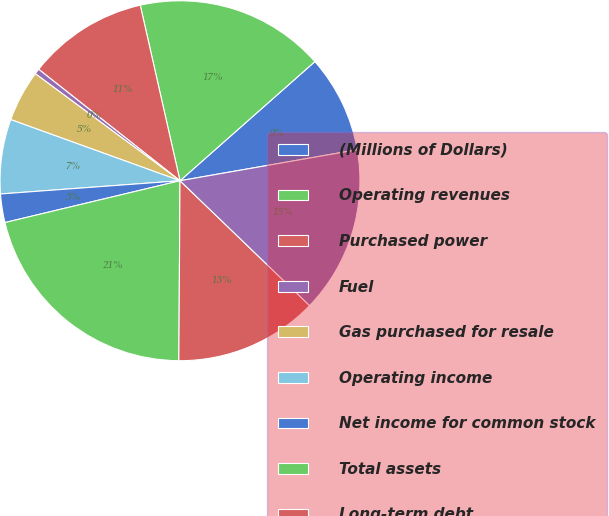<chart> <loc_0><loc_0><loc_500><loc_500><pie_chart><fcel>(Millions of Dollars)<fcel>Operating revenues<fcel>Purchased power<fcel>Fuel<fcel>Gas purchased for resale<fcel>Operating income<fcel>Net income for common stock<fcel>Total assets<fcel>Long-term debt<fcel>Common shareholder's equity<nl><fcel>8.76%<fcel>17.03%<fcel>10.83%<fcel>0.49%<fcel>4.62%<fcel>6.69%<fcel>2.56%<fcel>21.17%<fcel>12.9%<fcel>14.96%<nl></chart> 